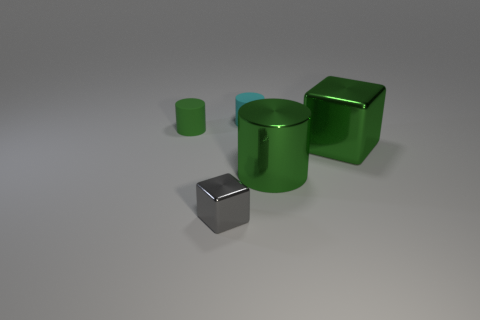Subtract all small green rubber cylinders. How many cylinders are left? 2 Subtract all green blocks. How many green cylinders are left? 2 Subtract 1 cylinders. How many cylinders are left? 2 Add 3 big metallic cylinders. How many objects exist? 8 Subtract 1 green cubes. How many objects are left? 4 Subtract all cubes. How many objects are left? 3 Subtract all yellow cylinders. Subtract all cyan balls. How many cylinders are left? 3 Subtract all blue cubes. Subtract all tiny green rubber objects. How many objects are left? 4 Add 5 tiny cyan rubber objects. How many tiny cyan rubber objects are left? 6 Add 1 tiny blue cylinders. How many tiny blue cylinders exist? 1 